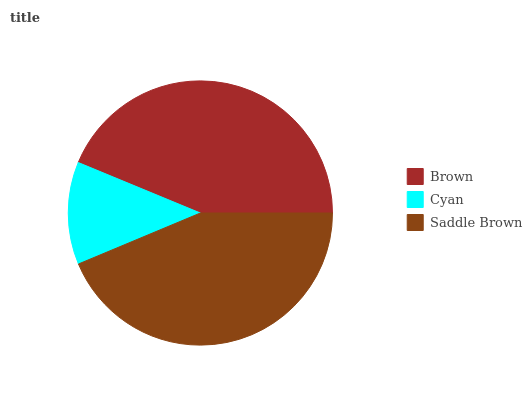Is Cyan the minimum?
Answer yes or no. Yes. Is Brown the maximum?
Answer yes or no. Yes. Is Saddle Brown the minimum?
Answer yes or no. No. Is Saddle Brown the maximum?
Answer yes or no. No. Is Saddle Brown greater than Cyan?
Answer yes or no. Yes. Is Cyan less than Saddle Brown?
Answer yes or no. Yes. Is Cyan greater than Saddle Brown?
Answer yes or no. No. Is Saddle Brown less than Cyan?
Answer yes or no. No. Is Saddle Brown the high median?
Answer yes or no. Yes. Is Saddle Brown the low median?
Answer yes or no. Yes. Is Brown the high median?
Answer yes or no. No. Is Cyan the low median?
Answer yes or no. No. 